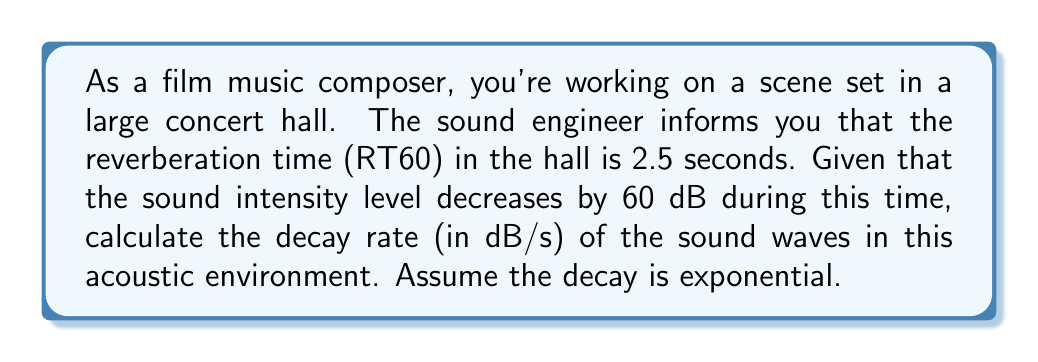Give your solution to this math problem. To solve this problem, we need to understand the relationship between reverberation time (RT60) and the decay rate of sound waves. The RT60 is the time it takes for the sound intensity to decrease by 60 dB.

Given:
- RT60 = 2.5 seconds
- Total decay = 60 dB

Step 1: Determine the decay rate formula
The decay rate (R) can be calculated by dividing the total decay by the time it takes to achieve that decay:

$$R = \frac{\text{Total Decay}}{\text{Time}}$$

Step 2: Plug in the known values
$$R = \frac{60 \text{ dB}}{2.5 \text{ s}}$$

Step 3: Perform the calculation
$$R = 24 \text{ dB/s}$$

This result means that in this concert hall, the sound intensity level decreases by 24 dB every second.

It's worth noting that this is an average decay rate, as the actual decay is exponential. In reality, the decay would be faster initially and slow down over time. However, for practical purposes in acoustics and audio engineering, this linear approximation is often used.

Understanding decay rates is crucial for film music composers, as it affects how music and sound effects will be perceived in different acoustic environments, influencing mixing decisions and potentially the composition itself.
Answer: 24 dB/s 